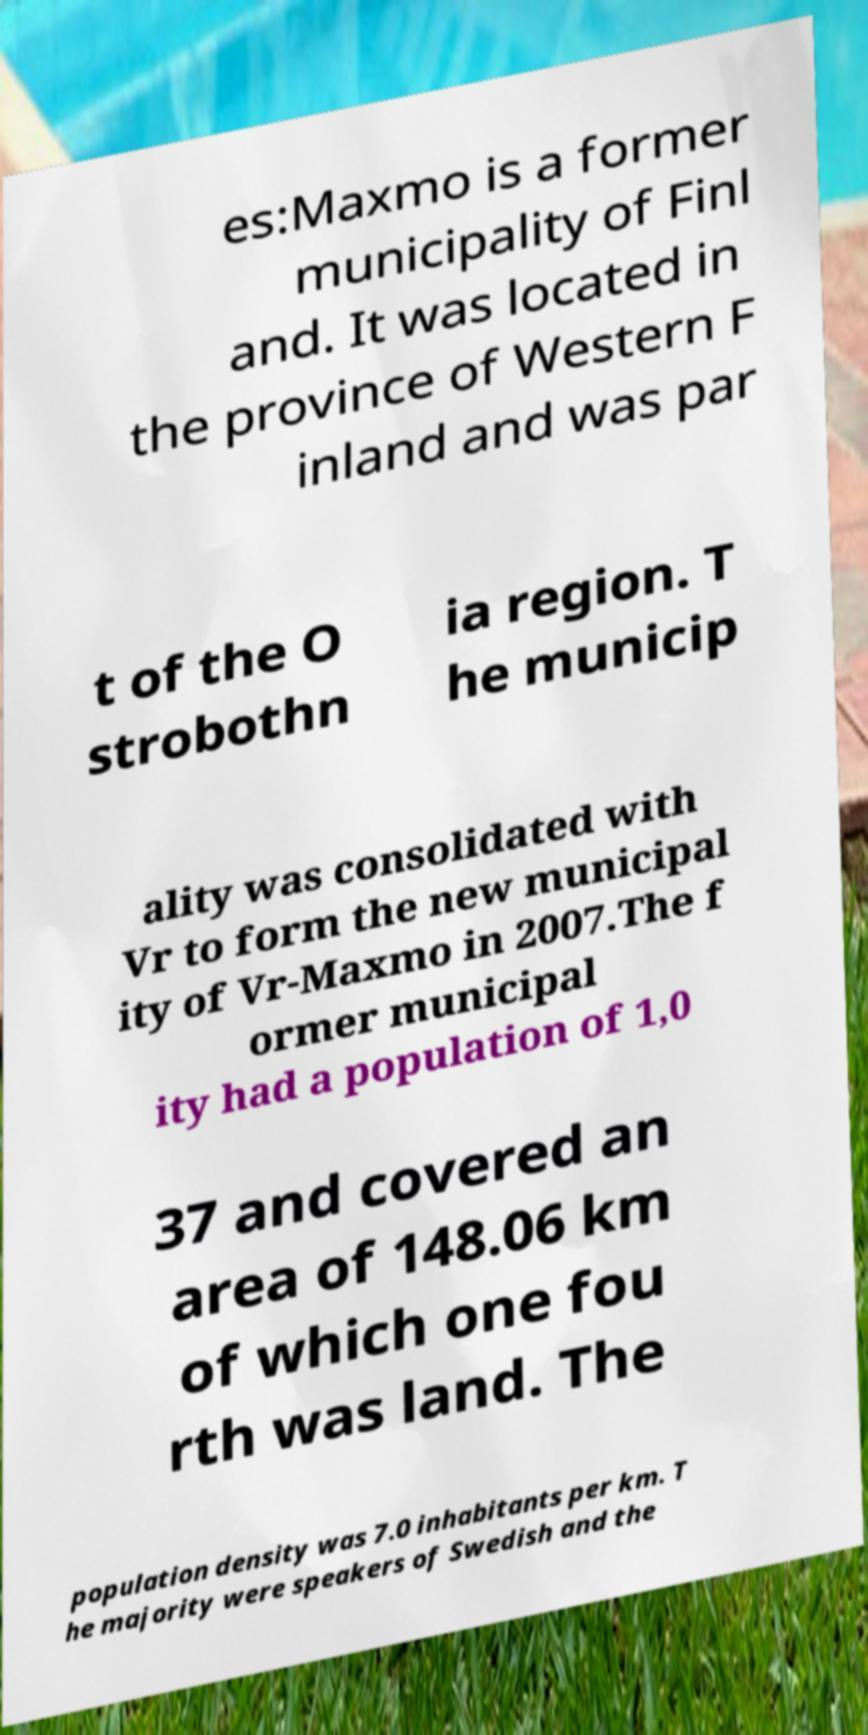For documentation purposes, I need the text within this image transcribed. Could you provide that? es:Maxmo is a former municipality of Finl and. It was located in the province of Western F inland and was par t of the O strobothn ia region. T he municip ality was consolidated with Vr to form the new municipal ity of Vr-Maxmo in 2007.The f ormer municipal ity had a population of 1,0 37 and covered an area of 148.06 km of which one fou rth was land. The population density was 7.0 inhabitants per km. T he majority were speakers of Swedish and the 